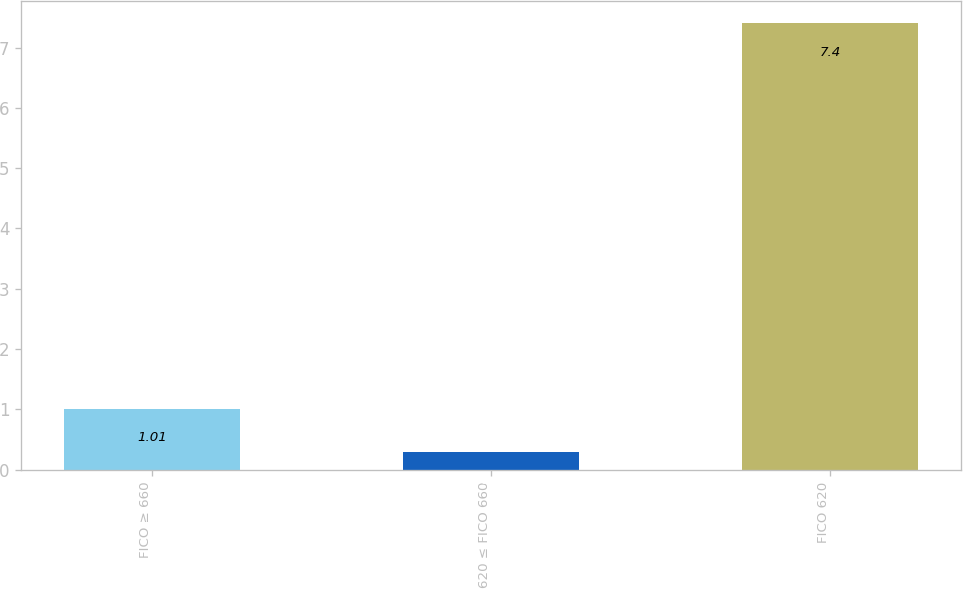<chart> <loc_0><loc_0><loc_500><loc_500><bar_chart><fcel>FICO ≥ 660<fcel>620 ≤ FICO 660<fcel>FICO 620<nl><fcel>1.01<fcel>0.3<fcel>7.4<nl></chart> 